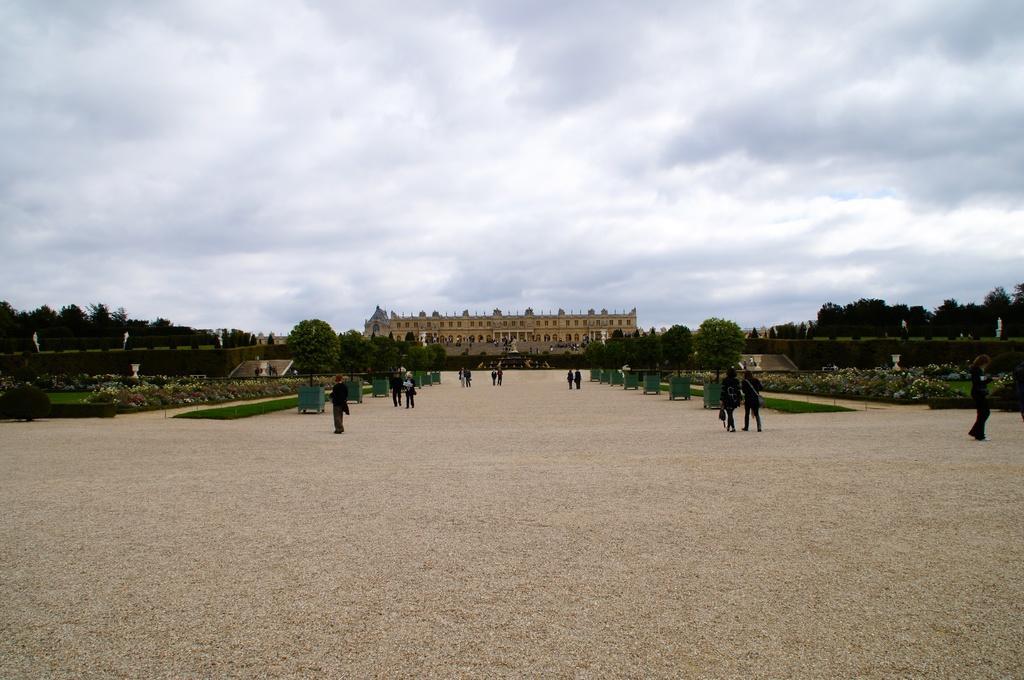How would you summarize this image in a sentence or two? In this image I can see so many people standing on the ground, beside them there are so many trees, at the back there is a building. 